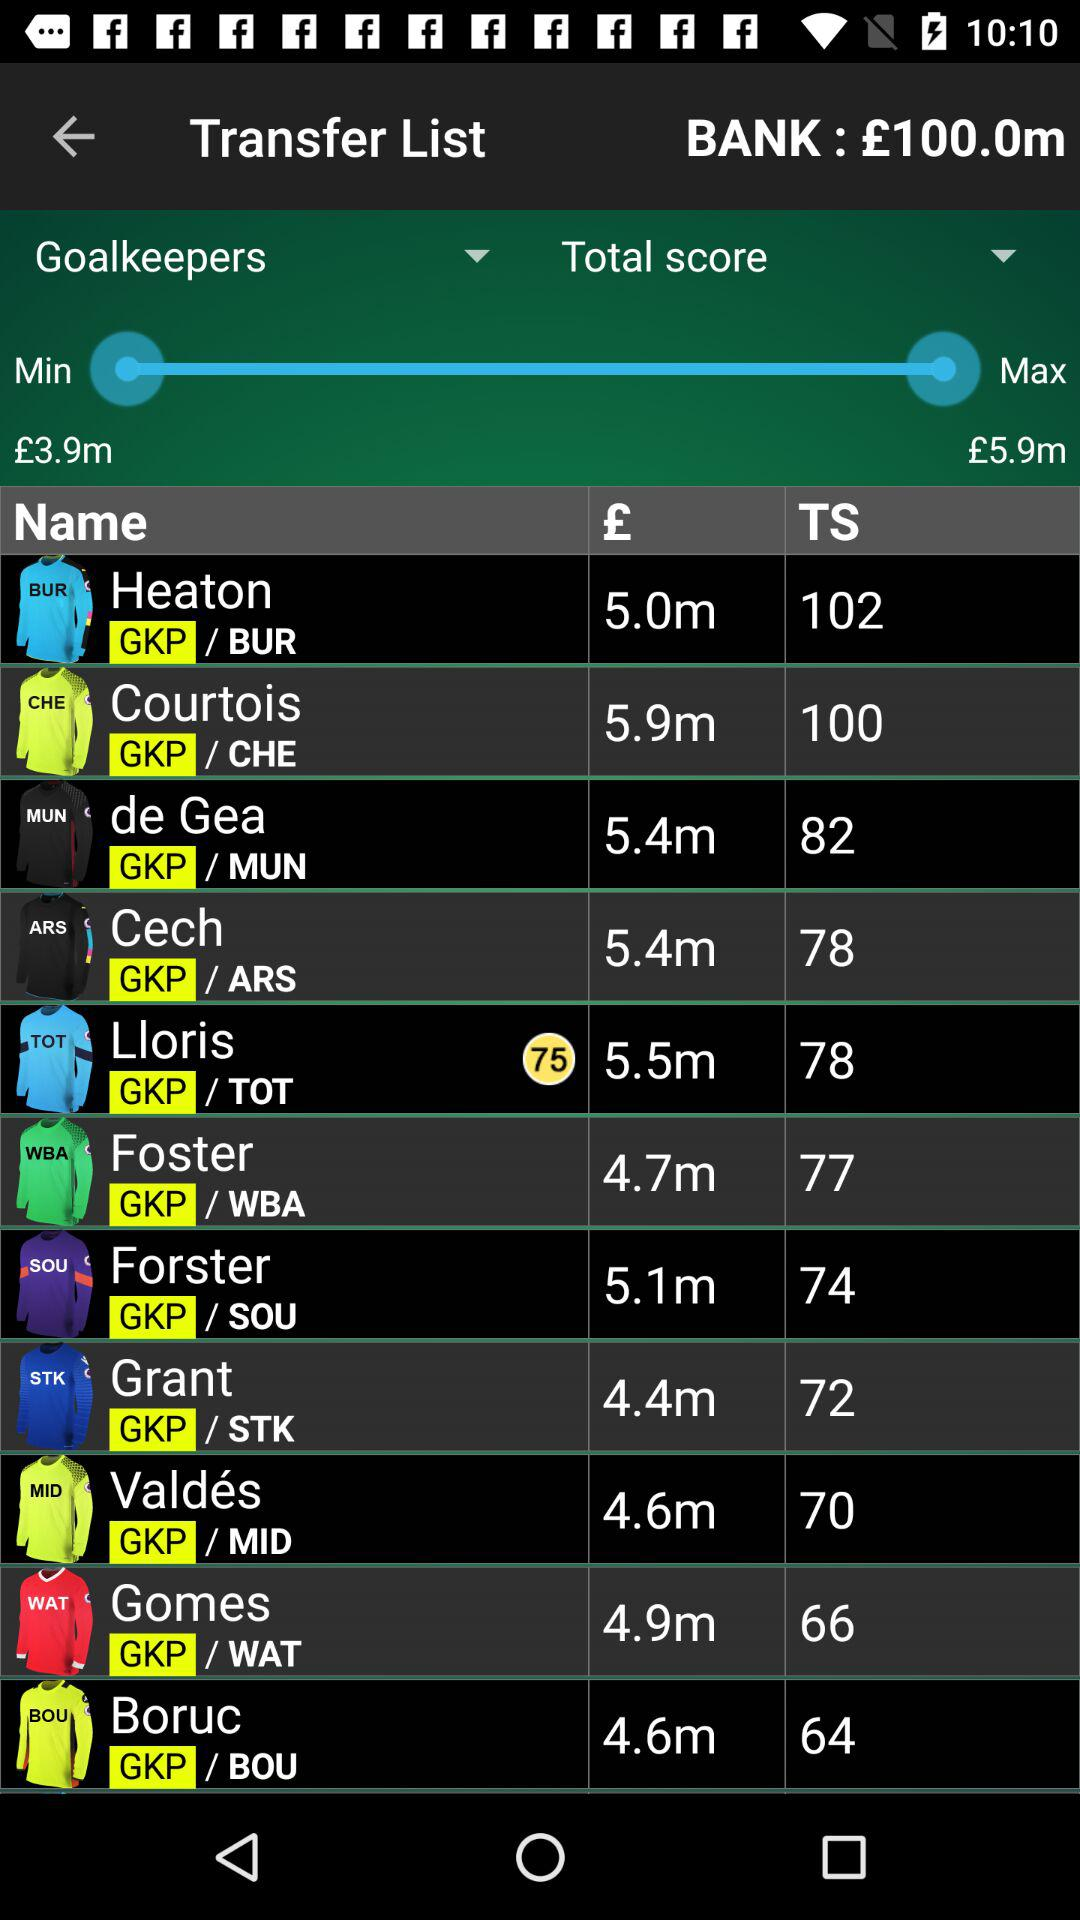What's the total score of Grant? Grant's total score is 72. 